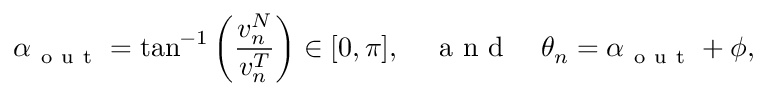Convert formula to latex. <formula><loc_0><loc_0><loc_500><loc_500>\alpha _ { o u t } = \tan ^ { - 1 } \left ( \frac { v _ { n } ^ { N } } { v _ { n } ^ { T } } \right ) \in [ 0 , \pi ] , \quad a n d \quad \theta _ { n } = \alpha _ { o u t } + \phi ,</formula> 